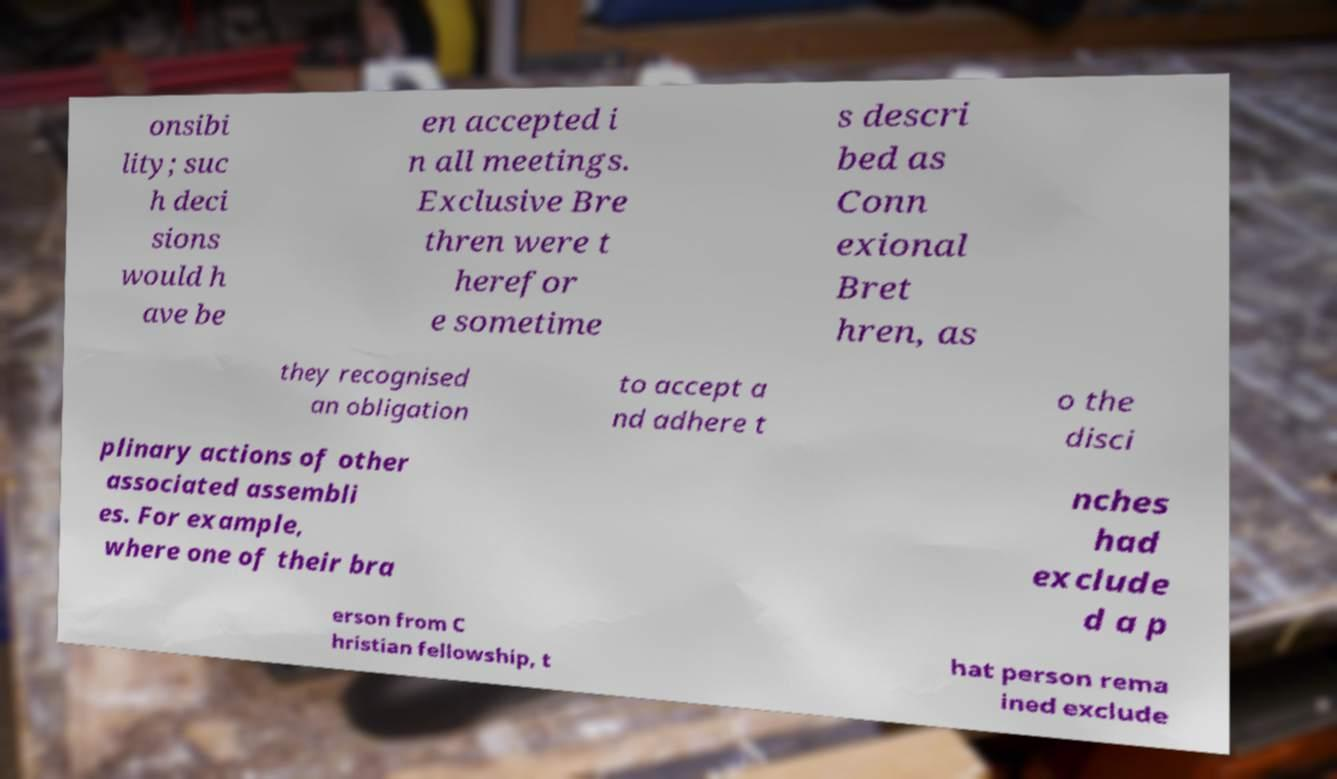Please identify and transcribe the text found in this image. onsibi lity; suc h deci sions would h ave be en accepted i n all meetings. Exclusive Bre thren were t herefor e sometime s descri bed as Conn exional Bret hren, as they recognised an obligation to accept a nd adhere t o the disci plinary actions of other associated assembli es. For example, where one of their bra nches had exclude d a p erson from C hristian fellowship, t hat person rema ined exclude 